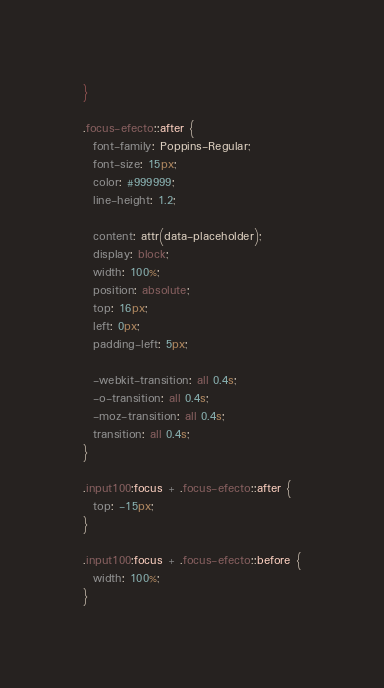Convert code to text. <code><loc_0><loc_0><loc_500><loc_500><_CSS_>}

.focus-efecto::after {
  font-family: Poppins-Regular;
  font-size: 15px;
  color: #999999;
  line-height: 1.2;

  content: attr(data-placeholder);
  display: block;
  width: 100%;
  position: absolute;
  top: 16px;
  left: 0px;
  padding-left: 5px;

  -webkit-transition: all 0.4s;
  -o-transition: all 0.4s;
  -moz-transition: all 0.4s;
  transition: all 0.4s;
}

.input100:focus + .focus-efecto::after {
  top: -15px;
}

.input100:focus + .focus-efecto::before {
  width: 100%;
}
</code> 